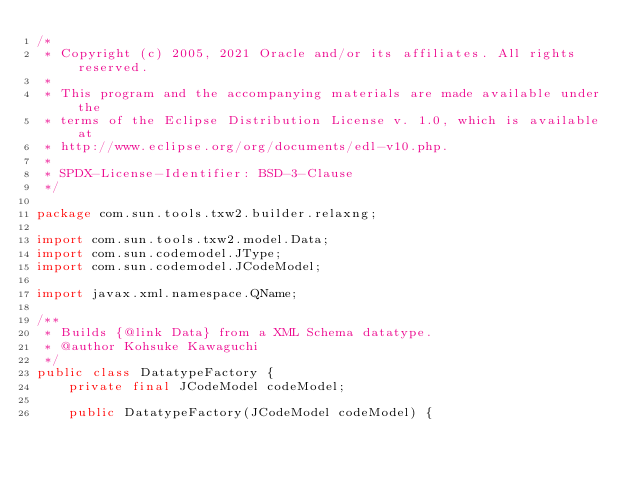Convert code to text. <code><loc_0><loc_0><loc_500><loc_500><_Java_>/*
 * Copyright (c) 2005, 2021 Oracle and/or its affiliates. All rights reserved.
 *
 * This program and the accompanying materials are made available under the
 * terms of the Eclipse Distribution License v. 1.0, which is available at
 * http://www.eclipse.org/org/documents/edl-v10.php.
 *
 * SPDX-License-Identifier: BSD-3-Clause
 */

package com.sun.tools.txw2.builder.relaxng;

import com.sun.tools.txw2.model.Data;
import com.sun.codemodel.JType;
import com.sun.codemodel.JCodeModel;

import javax.xml.namespace.QName;

/**
 * Builds {@link Data} from a XML Schema datatype.
 * @author Kohsuke Kawaguchi
 */
public class DatatypeFactory {
    private final JCodeModel codeModel;

    public DatatypeFactory(JCodeModel codeModel) {</code> 